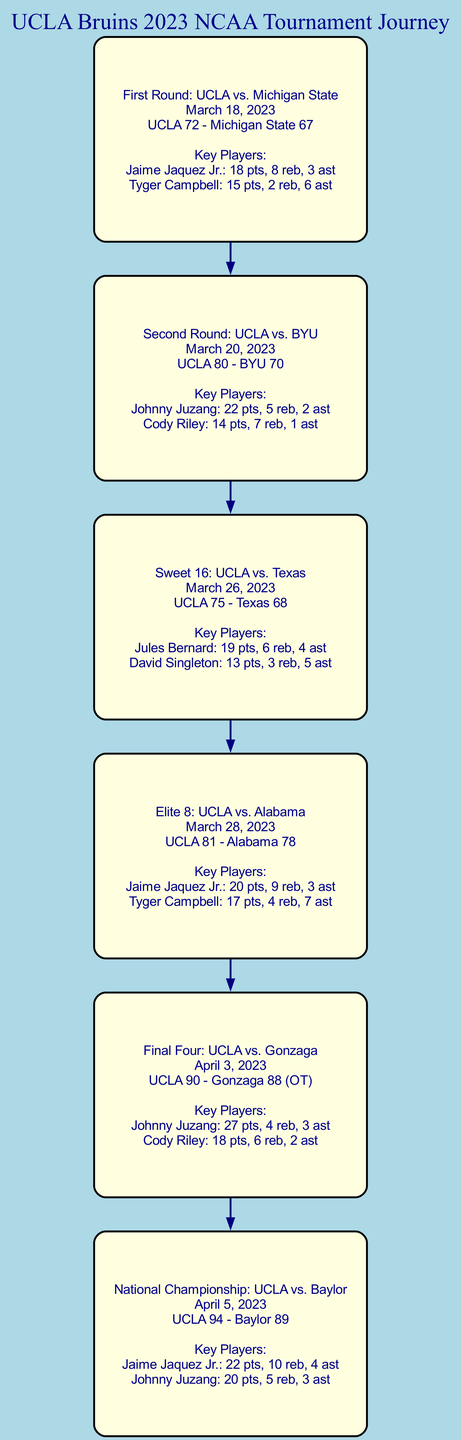What was the score of the First Round game? The score of the First Round game is displayed in the node labeled "First Round: UCLA vs. Michigan State" as "UCLA 72 - Michigan State 67".
Answer: UCLA 72 - Michigan State 67 Who were the key players in the Final Four game? The Final Four game node labeled "Final Four: UCLA vs. Gonzaga" lists "Johnny Juzang" and "Cody Riley" as key players.
Answer: Johnny Juzang and Cody Riley How many games did UCLA play in total during the playoffs? By counting the nodes, each representing a game, we see there are 6 nodes: game1, game2, game3, game4, game5, and game6.
Answer: 6 What was the date of the National Championship game? The date is provided in the "National Championship: UCLA vs. Baylor" node, which states the date as "April 5, 2023".
Answer: April 5, 2023 Which game had the highest score for UCLA? The highest score for UCLA is found in the node for the "Final Four: UCLA vs. Gonzaga", where the score is "UCLA 90".
Answer: UCLA 90 How many points did Jaime Jaquez Jr. score in the Elite 8 game? In the node labeled "Elite 8: UCLA vs. Alabama", the details state that Jaime Jaquez Jr. scored 20 points.
Answer: 20 Which opponent did UCLA face in the Sweet 16? The Sweet 16 game node is labeled "Sweet 16: UCLA vs. Texas", indicating that Texas was the opponent.
Answer: Texas What was the score in the game against BYU? The score of the Second Round game against BYU is displayed in the corresponding node as "UCLA 80 - BYU 70".
Answer: UCLA 80 - BYU 70 How many assists did Tyger Campbell have in the First Round? In the "First Round: UCLA vs. Michigan State" node, Tyger Campbell's assists are noted as 6.
Answer: 6 